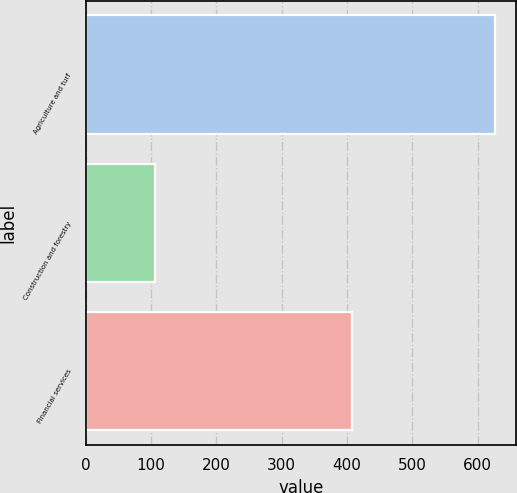Convert chart to OTSL. <chart><loc_0><loc_0><loc_500><loc_500><bar_chart><fcel>Agriculture and turf<fcel>Construction and forestry<fcel>Financial services<nl><fcel>627<fcel>106<fcel>407<nl></chart> 